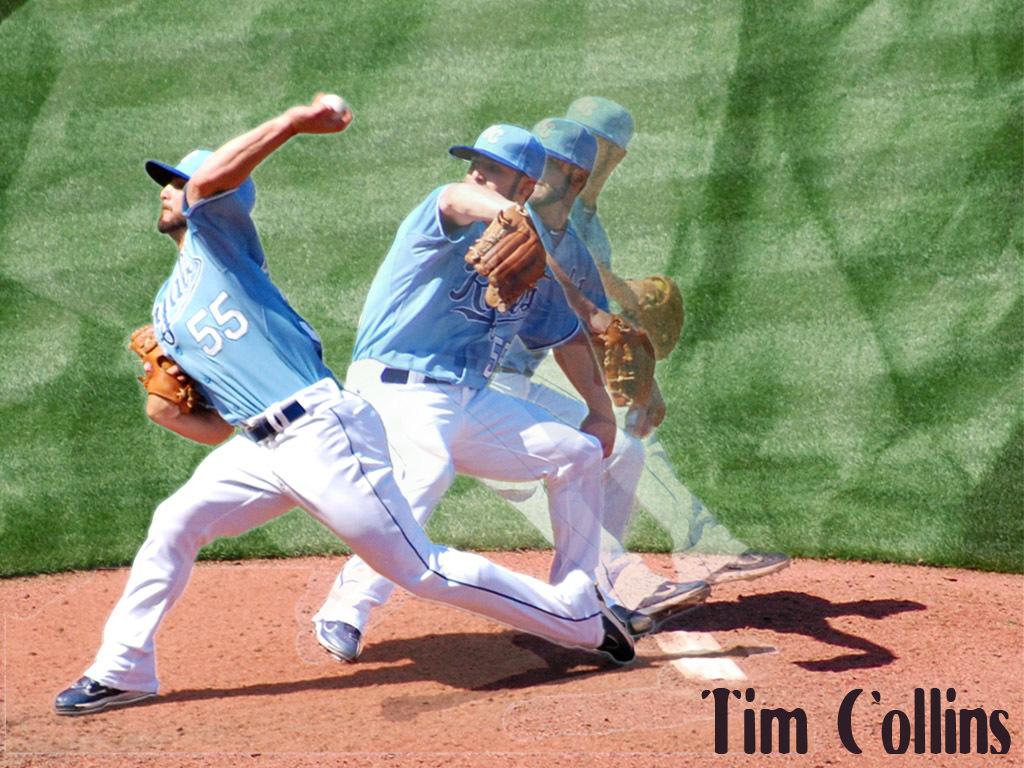What color is the number on the jersey?
Keep it short and to the point. White. 